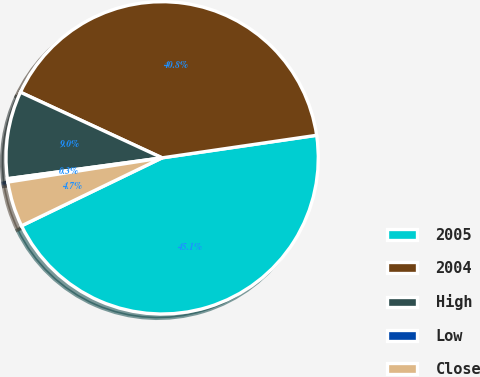<chart> <loc_0><loc_0><loc_500><loc_500><pie_chart><fcel>2005<fcel>2004<fcel>High<fcel>Low<fcel>Close<nl><fcel>45.14%<fcel>40.79%<fcel>9.04%<fcel>0.34%<fcel>4.69%<nl></chart> 